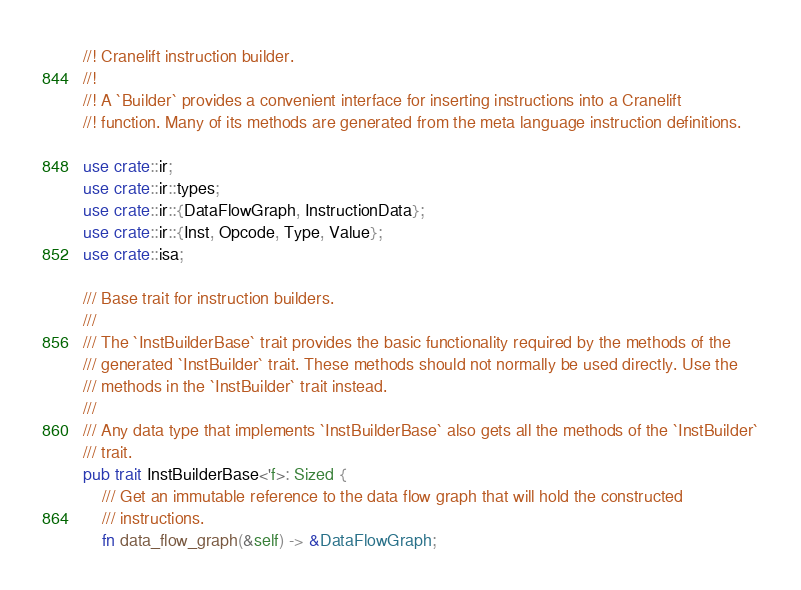Convert code to text. <code><loc_0><loc_0><loc_500><loc_500><_Rust_>//! Cranelift instruction builder.
//!
//! A `Builder` provides a convenient interface for inserting instructions into a Cranelift
//! function. Many of its methods are generated from the meta language instruction definitions.

use crate::ir;
use crate::ir::types;
use crate::ir::{DataFlowGraph, InstructionData};
use crate::ir::{Inst, Opcode, Type, Value};
use crate::isa;

/// Base trait for instruction builders.
///
/// The `InstBuilderBase` trait provides the basic functionality required by the methods of the
/// generated `InstBuilder` trait. These methods should not normally be used directly. Use the
/// methods in the `InstBuilder` trait instead.
///
/// Any data type that implements `InstBuilderBase` also gets all the methods of the `InstBuilder`
/// trait.
pub trait InstBuilderBase<'f>: Sized {
    /// Get an immutable reference to the data flow graph that will hold the constructed
    /// instructions.
    fn data_flow_graph(&self) -> &DataFlowGraph;</code> 